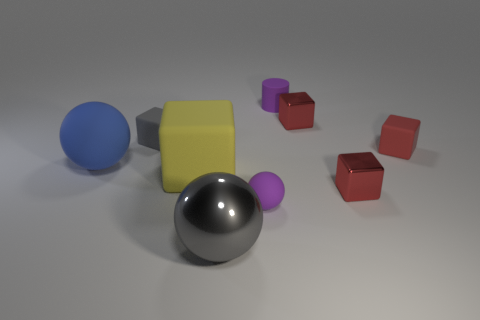Subtract all brown cylinders. How many red cubes are left? 3 Subtract all red rubber blocks. How many blocks are left? 4 Subtract all gray blocks. How many blocks are left? 4 Subtract all purple cubes. Subtract all cyan cylinders. How many cubes are left? 5 Add 1 big brown metallic blocks. How many objects exist? 10 Subtract all cylinders. How many objects are left? 8 Add 9 small gray matte blocks. How many small gray matte blocks exist? 10 Subtract 2 red blocks. How many objects are left? 7 Subtract all purple cylinders. Subtract all big yellow rubber cubes. How many objects are left? 7 Add 3 tiny purple cylinders. How many tiny purple cylinders are left? 4 